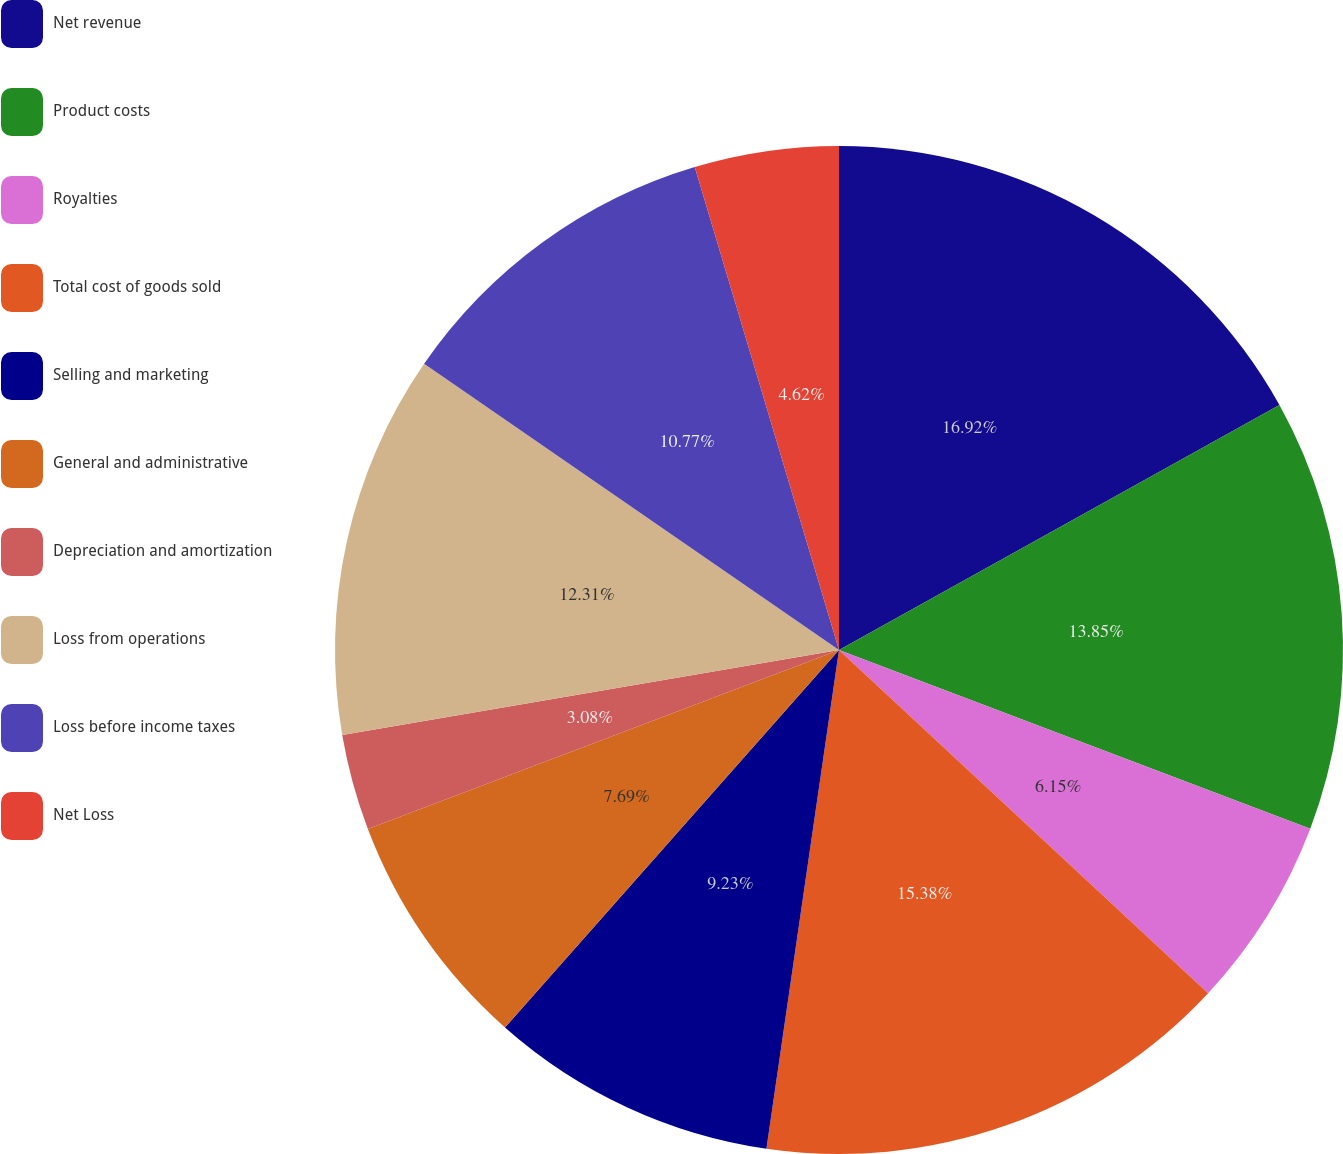Convert chart to OTSL. <chart><loc_0><loc_0><loc_500><loc_500><pie_chart><fcel>Net revenue<fcel>Product costs<fcel>Royalties<fcel>Total cost of goods sold<fcel>Selling and marketing<fcel>General and administrative<fcel>Depreciation and amortization<fcel>Loss from operations<fcel>Loss before income taxes<fcel>Net Loss<nl><fcel>16.92%<fcel>13.85%<fcel>6.15%<fcel>15.38%<fcel>9.23%<fcel>7.69%<fcel>3.08%<fcel>12.31%<fcel>10.77%<fcel>4.62%<nl></chart> 